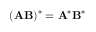Convert formula to latex. <formula><loc_0><loc_0><loc_500><loc_500>( A B ) ^ { * } = A ^ { * } B ^ { * }</formula> 